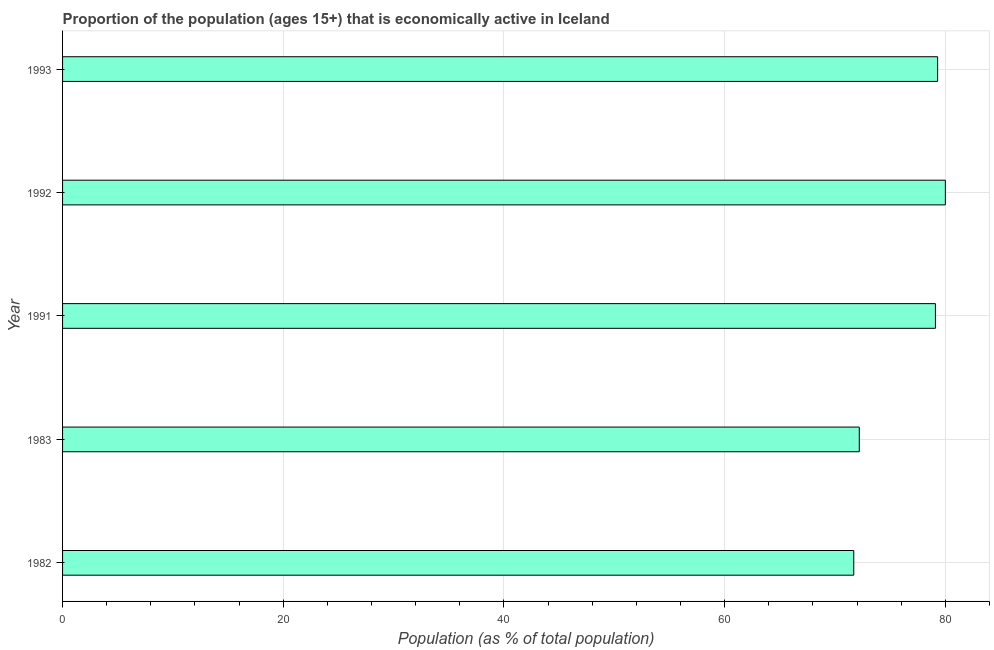Does the graph contain any zero values?
Your response must be concise. No. What is the title of the graph?
Your answer should be compact. Proportion of the population (ages 15+) that is economically active in Iceland. What is the label or title of the X-axis?
Ensure brevity in your answer.  Population (as % of total population). What is the label or title of the Y-axis?
Ensure brevity in your answer.  Year. Across all years, what is the maximum percentage of economically active population?
Ensure brevity in your answer.  80. Across all years, what is the minimum percentage of economically active population?
Make the answer very short. 71.7. In which year was the percentage of economically active population maximum?
Provide a short and direct response. 1992. In which year was the percentage of economically active population minimum?
Ensure brevity in your answer.  1982. What is the sum of the percentage of economically active population?
Make the answer very short. 382.3. What is the average percentage of economically active population per year?
Keep it short and to the point. 76.46. What is the median percentage of economically active population?
Ensure brevity in your answer.  79.1. In how many years, is the percentage of economically active population greater than 4 %?
Give a very brief answer. 5. Do a majority of the years between 1982 and 1983 (inclusive) have percentage of economically active population greater than 80 %?
Your response must be concise. No. What is the ratio of the percentage of economically active population in 1983 to that in 1993?
Keep it short and to the point. 0.91. Is the percentage of economically active population in 1982 less than that in 1991?
Provide a succinct answer. Yes. Is the sum of the percentage of economically active population in 1991 and 1992 greater than the maximum percentage of economically active population across all years?
Provide a succinct answer. Yes. What is the difference between the highest and the lowest percentage of economically active population?
Your response must be concise. 8.3. In how many years, is the percentage of economically active population greater than the average percentage of economically active population taken over all years?
Your response must be concise. 3. How many bars are there?
Your answer should be very brief. 5. What is the Population (as % of total population) in 1982?
Your answer should be very brief. 71.7. What is the Population (as % of total population) in 1983?
Make the answer very short. 72.2. What is the Population (as % of total population) in 1991?
Ensure brevity in your answer.  79.1. What is the Population (as % of total population) in 1992?
Provide a succinct answer. 80. What is the Population (as % of total population) in 1993?
Offer a terse response. 79.3. What is the difference between the Population (as % of total population) in 1982 and 1991?
Make the answer very short. -7.4. What is the difference between the Population (as % of total population) in 1982 and 1992?
Your answer should be very brief. -8.3. What is the difference between the Population (as % of total population) in 1982 and 1993?
Your response must be concise. -7.6. What is the difference between the Population (as % of total population) in 1983 and 1991?
Keep it short and to the point. -6.9. What is the difference between the Population (as % of total population) in 1983 and 1992?
Make the answer very short. -7.8. What is the difference between the Population (as % of total population) in 1983 and 1993?
Offer a very short reply. -7.1. What is the difference between the Population (as % of total population) in 1991 and 1992?
Provide a succinct answer. -0.9. What is the difference between the Population (as % of total population) in 1991 and 1993?
Provide a short and direct response. -0.2. What is the ratio of the Population (as % of total population) in 1982 to that in 1983?
Your response must be concise. 0.99. What is the ratio of the Population (as % of total population) in 1982 to that in 1991?
Make the answer very short. 0.91. What is the ratio of the Population (as % of total population) in 1982 to that in 1992?
Your response must be concise. 0.9. What is the ratio of the Population (as % of total population) in 1982 to that in 1993?
Provide a succinct answer. 0.9. What is the ratio of the Population (as % of total population) in 1983 to that in 1992?
Your answer should be compact. 0.9. What is the ratio of the Population (as % of total population) in 1983 to that in 1993?
Provide a short and direct response. 0.91. What is the ratio of the Population (as % of total population) in 1991 to that in 1993?
Provide a short and direct response. 1. 